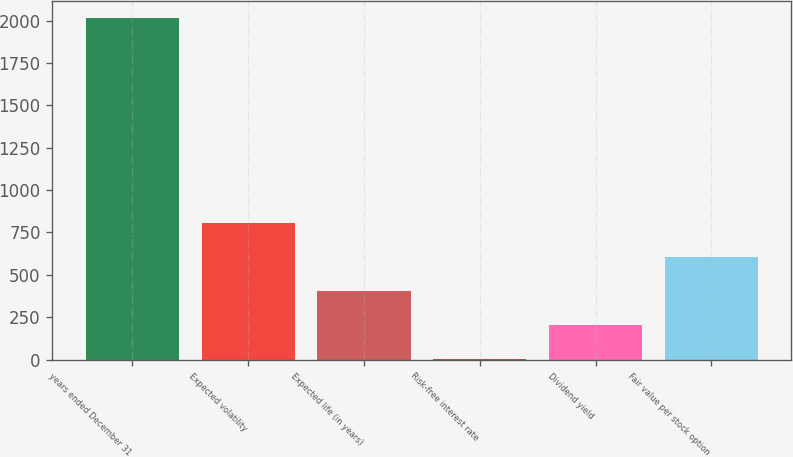Convert chart. <chart><loc_0><loc_0><loc_500><loc_500><bar_chart><fcel>years ended December 31<fcel>Expected volatility<fcel>Expected life (in years)<fcel>Risk-free interest rate<fcel>Dividend yield<fcel>Fair value per stock option<nl><fcel>2013<fcel>805.74<fcel>403.32<fcel>0.9<fcel>202.11<fcel>604.53<nl></chart> 